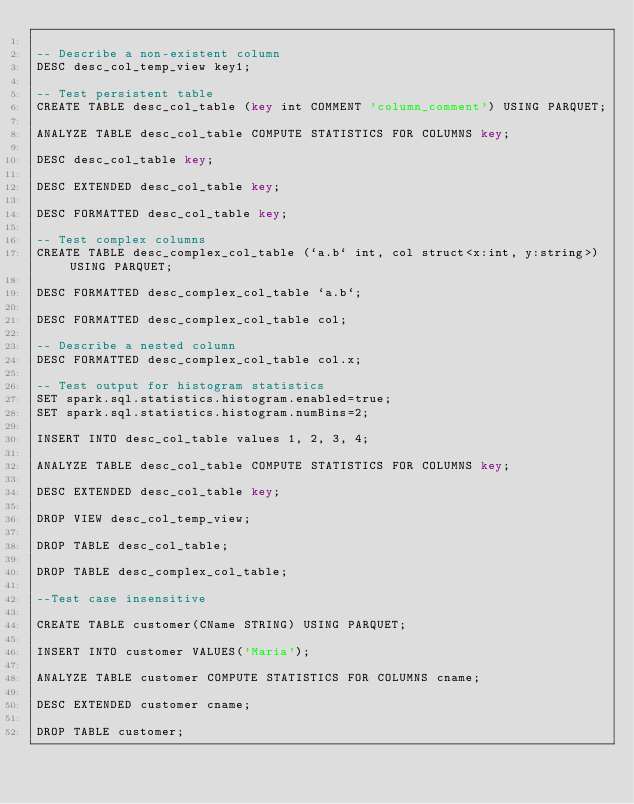Convert code to text. <code><loc_0><loc_0><loc_500><loc_500><_SQL_>
-- Describe a non-existent column
DESC desc_col_temp_view key1;

-- Test persistent table
CREATE TABLE desc_col_table (key int COMMENT 'column_comment') USING PARQUET;

ANALYZE TABLE desc_col_table COMPUTE STATISTICS FOR COLUMNS key;

DESC desc_col_table key;

DESC EXTENDED desc_col_table key;

DESC FORMATTED desc_col_table key;

-- Test complex columns
CREATE TABLE desc_complex_col_table (`a.b` int, col struct<x:int, y:string>) USING PARQUET;

DESC FORMATTED desc_complex_col_table `a.b`;

DESC FORMATTED desc_complex_col_table col;

-- Describe a nested column
DESC FORMATTED desc_complex_col_table col.x;

-- Test output for histogram statistics
SET spark.sql.statistics.histogram.enabled=true;
SET spark.sql.statistics.histogram.numBins=2;

INSERT INTO desc_col_table values 1, 2, 3, 4;

ANALYZE TABLE desc_col_table COMPUTE STATISTICS FOR COLUMNS key;

DESC EXTENDED desc_col_table key;

DROP VIEW desc_col_temp_view;

DROP TABLE desc_col_table;

DROP TABLE desc_complex_col_table;

--Test case insensitive

CREATE TABLE customer(CName STRING) USING PARQUET;

INSERT INTO customer VALUES('Maria');

ANALYZE TABLE customer COMPUTE STATISTICS FOR COLUMNS cname;

DESC EXTENDED customer cname;

DROP TABLE customer;

</code> 